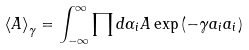<formula> <loc_0><loc_0><loc_500><loc_500>\left \langle A \right \rangle _ { \gamma } = \int _ { - \infty } ^ { \infty } \prod d \alpha _ { i } A \exp \left ( - \gamma a _ { i } a _ { i } \right )</formula> 